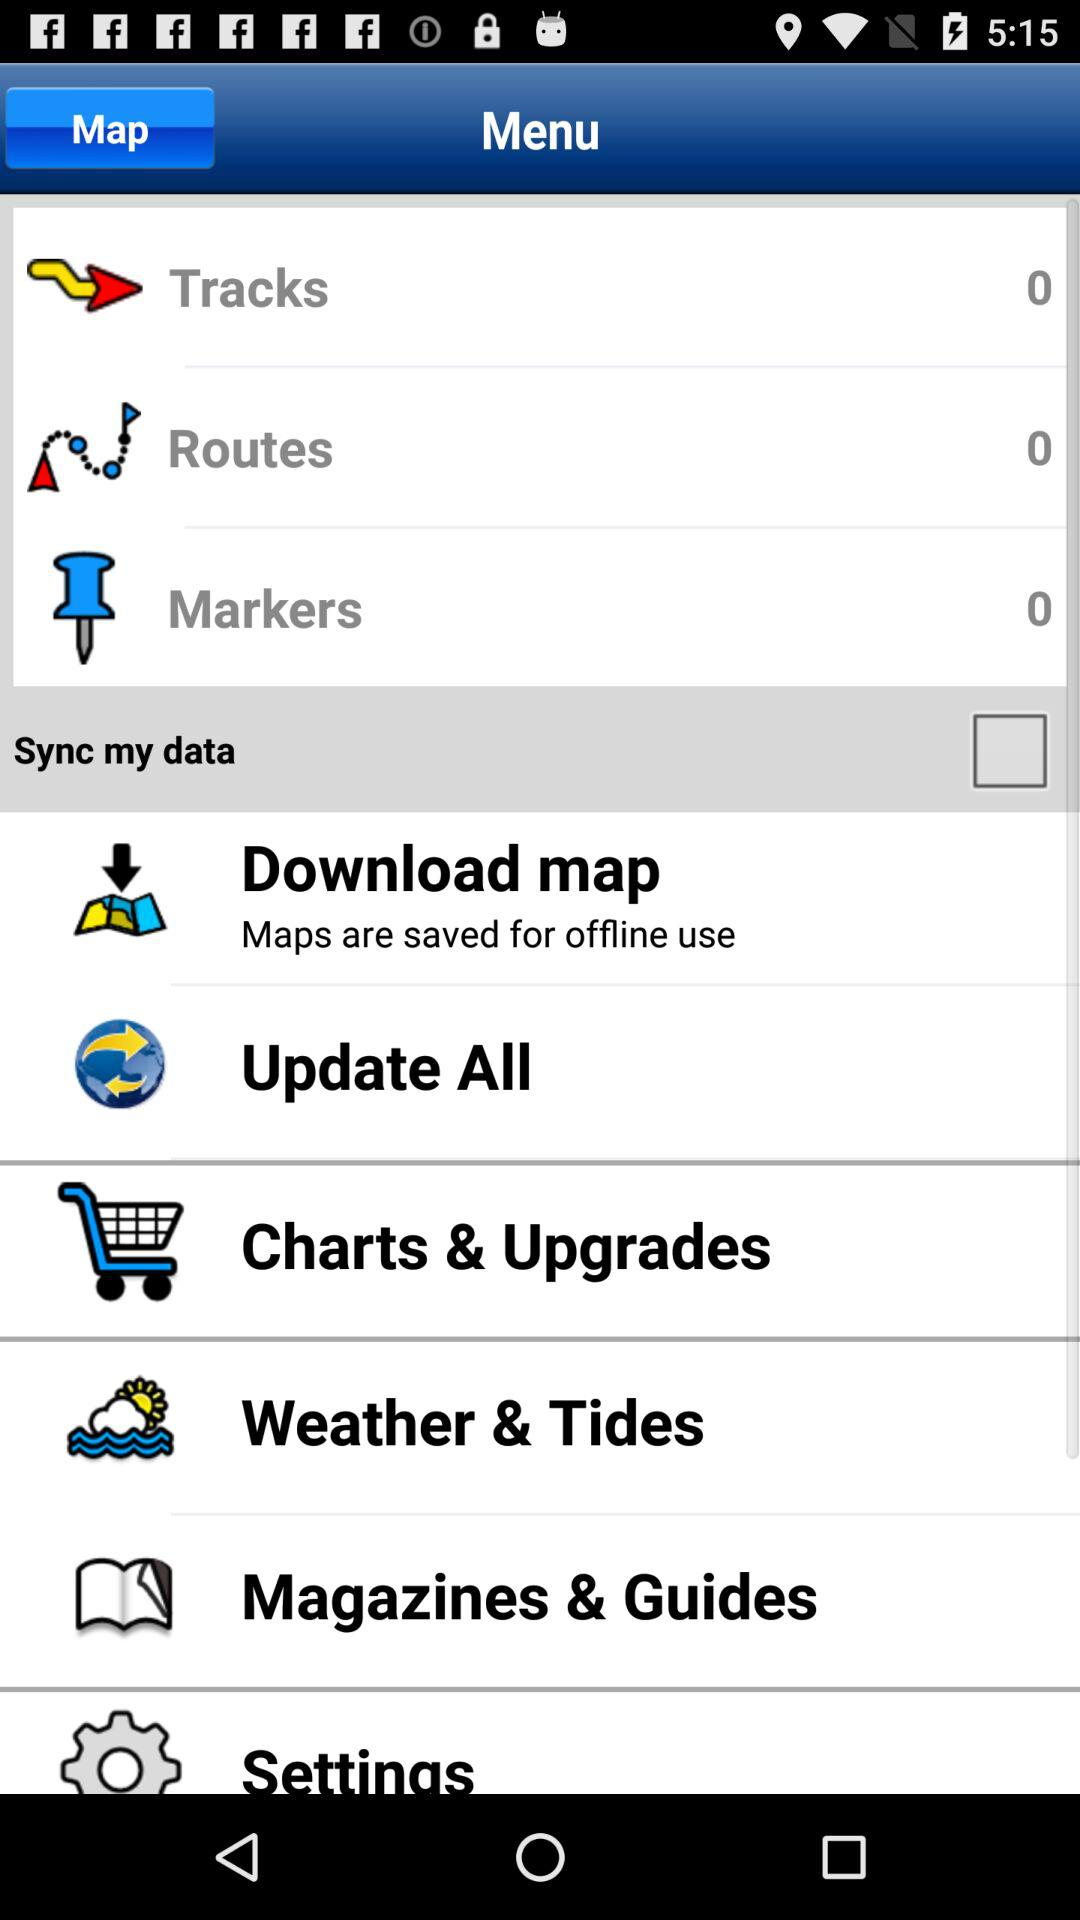Is "Sync my data" checked or unchecked? "Sync my data" is unchecked. 